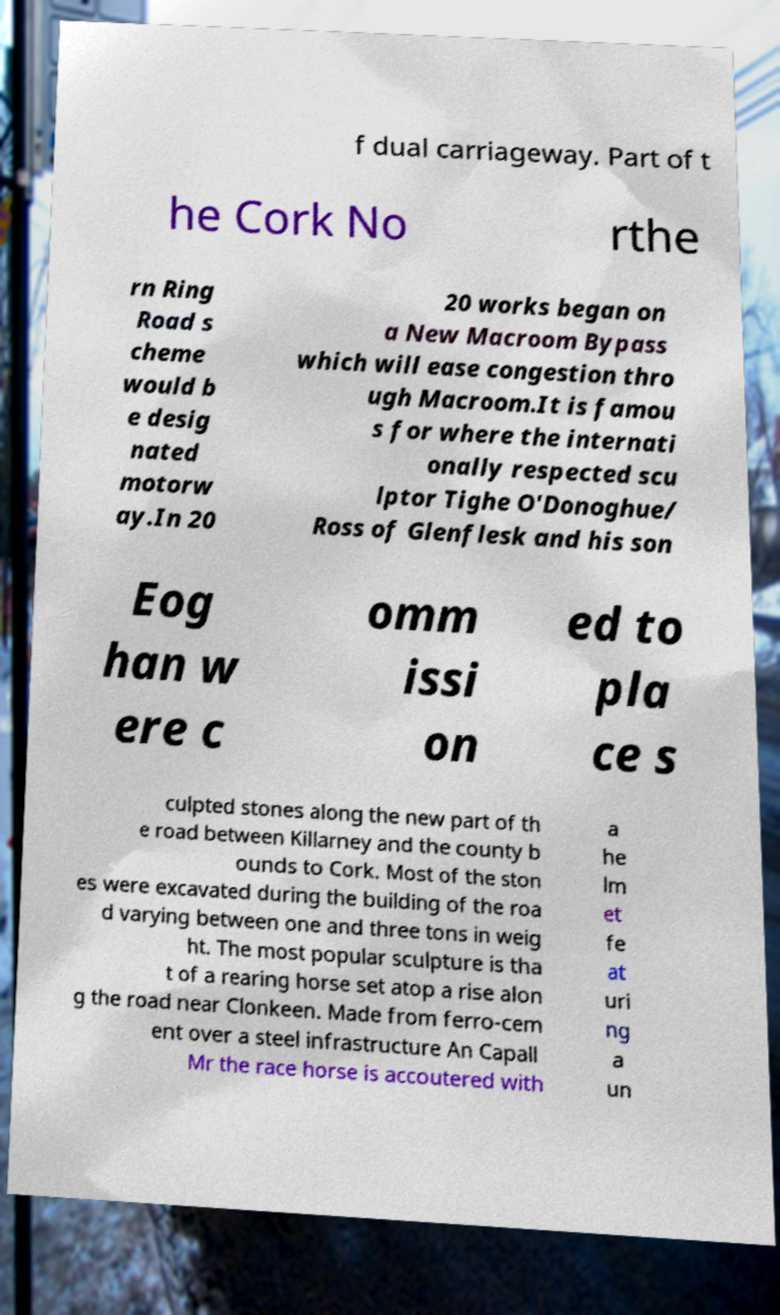Please identify and transcribe the text found in this image. f dual carriageway. Part of t he Cork No rthe rn Ring Road s cheme would b e desig nated motorw ay.In 20 20 works began on a New Macroom Bypass which will ease congestion thro ugh Macroom.It is famou s for where the internati onally respected scu lptor Tighe O'Donoghue/ Ross of Glenflesk and his son Eog han w ere c omm issi on ed to pla ce s culpted stones along the new part of th e road between Killarney and the county b ounds to Cork. Most of the ston es were excavated during the building of the roa d varying between one and three tons in weig ht. The most popular sculpture is tha t of a rearing horse set atop a rise alon g the road near Clonkeen. Made from ferro-cem ent over a steel infrastructure An Capall Mr the race horse is accoutered with a he lm et fe at uri ng a un 